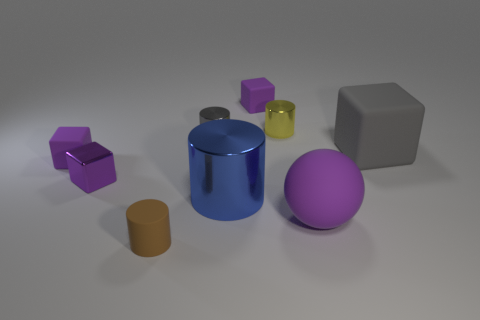Are there any big blue objects behind the large purple thing?
Ensure brevity in your answer.  Yes. How many matte objects are in front of the purple object in front of the big blue metal object?
Keep it short and to the point. 1. There is a brown cylinder that is the same size as the shiny cube; what material is it?
Offer a terse response. Rubber. What number of other objects are there of the same material as the large cylinder?
Provide a succinct answer. 3. How many metal cylinders are on the left side of the small yellow cylinder?
Give a very brief answer. 2. What number of cylinders are either gray metallic objects or big gray objects?
Give a very brief answer. 1. There is a thing that is both to the left of the large blue cylinder and behind the big gray matte cube; what is its size?
Keep it short and to the point. Small. What number of other things are there of the same color as the small matte cylinder?
Keep it short and to the point. 0. Is the material of the large blue thing the same as the purple thing in front of the blue object?
Keep it short and to the point. No. What number of objects are either gray things behind the gray matte cube or matte cylinders?
Your response must be concise. 2. 